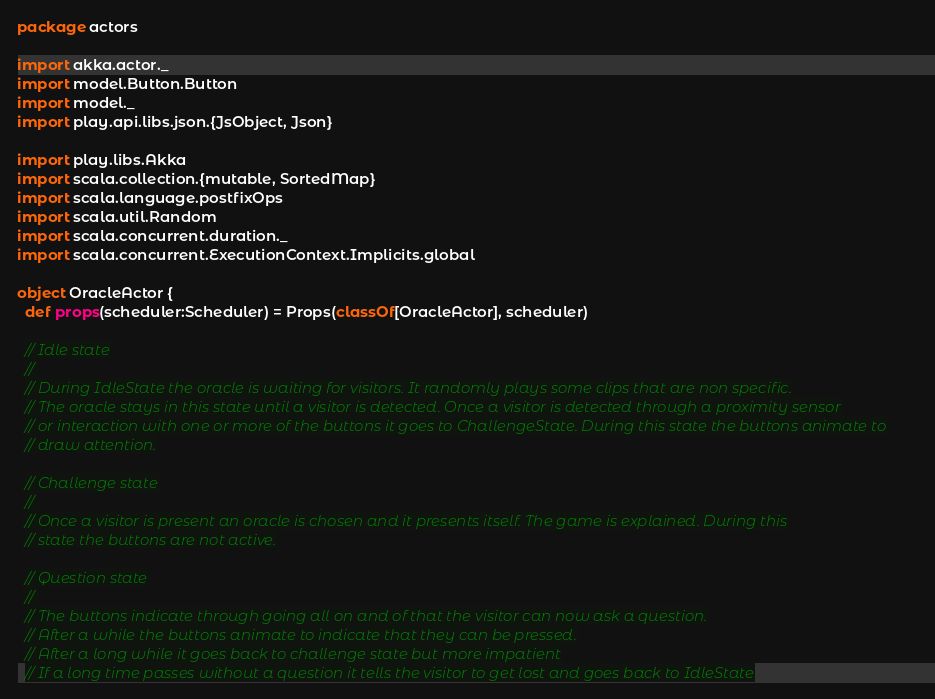<code> <loc_0><loc_0><loc_500><loc_500><_Scala_>package actors

import akka.actor._
import model.Button.Button
import model._
import play.api.libs.json.{JsObject, Json}

import play.libs.Akka
import scala.collection.{mutable, SortedMap}
import scala.language.postfixOps
import scala.util.Random
import scala.concurrent.duration._
import scala.concurrent.ExecutionContext.Implicits.global

object OracleActor {
  def props(scheduler:Scheduler) = Props(classOf[OracleActor], scheduler)

  // Idle state
  //
  // During IdleState the oracle is waiting for visitors. It randomly plays some clips that are non specific.
  // The oracle stays in this state until a visitor is detected. Once a visitor is detected through a proximity sensor
  // or interaction with one or more of the buttons it goes to ChallengeState. During this state the buttons animate to
  // draw attention.

  // Challenge state
  //
  // Once a visitor is present an oracle is chosen and it presents itself. The game is explained. During this
  // state the buttons are not active.

  // Question state
  //
  // The buttons indicate through going all on and of that the visitor can now ask a question.
  // After a while the buttons animate to indicate that they can be pressed.
  // After a long while it goes back to challenge state but more impatient
  // If a long time passes without a question it tells the visitor to get lost and goes back to IdleState</code> 